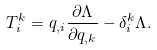<formula> <loc_0><loc_0><loc_500><loc_500>T ^ { k } _ { i } = q _ { , i } \frac { \partial \Lambda } { \partial q _ { , k } } - \delta ^ { k } _ { i } \Lambda .</formula> 